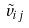<formula> <loc_0><loc_0><loc_500><loc_500>\tilde { v } _ { i j }</formula> 